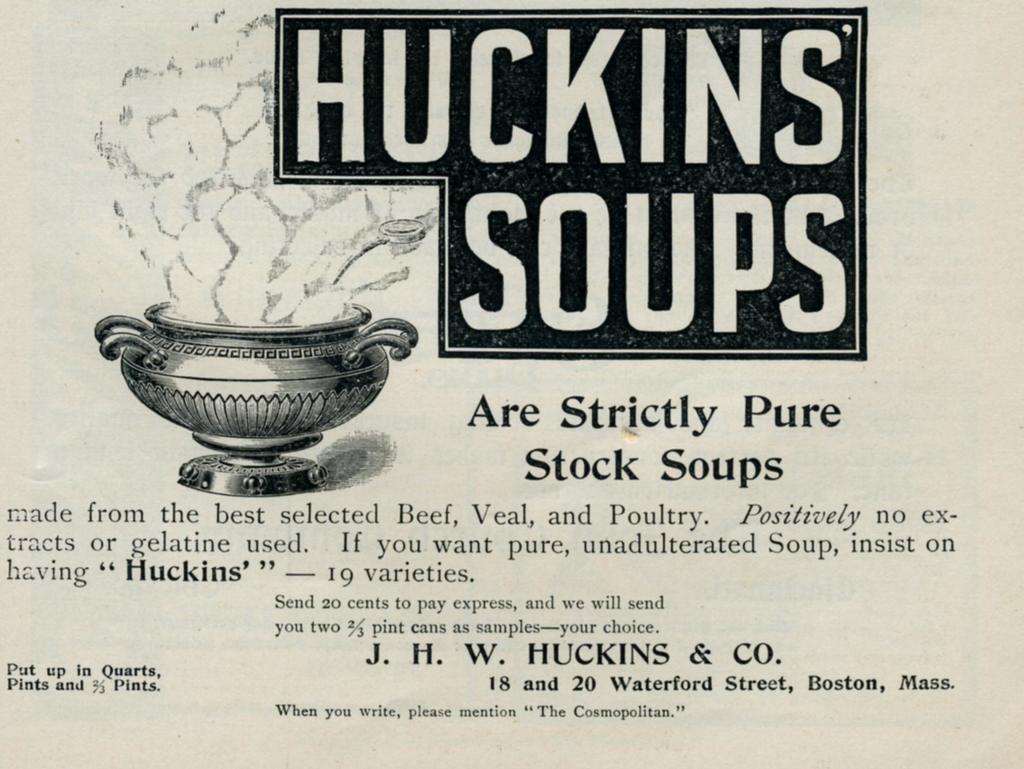Could you give a brief overview of what you see in this image? This looks like a black and white poster. I can see a picture of a pot. These are the letters on the poster. 